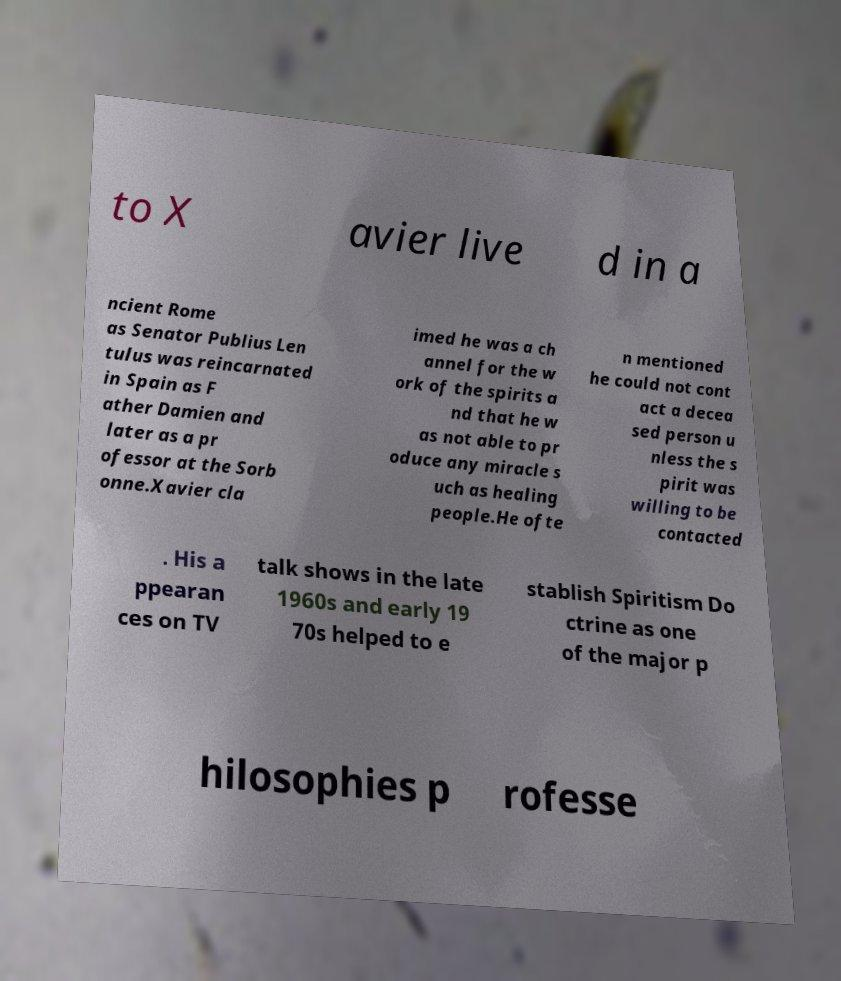I need the written content from this picture converted into text. Can you do that? to X avier live d in a ncient Rome as Senator Publius Len tulus was reincarnated in Spain as F ather Damien and later as a pr ofessor at the Sorb onne.Xavier cla imed he was a ch annel for the w ork of the spirits a nd that he w as not able to pr oduce any miracle s uch as healing people.He ofte n mentioned he could not cont act a decea sed person u nless the s pirit was willing to be contacted . His a ppearan ces on TV talk shows in the late 1960s and early 19 70s helped to e stablish Spiritism Do ctrine as one of the major p hilosophies p rofesse 